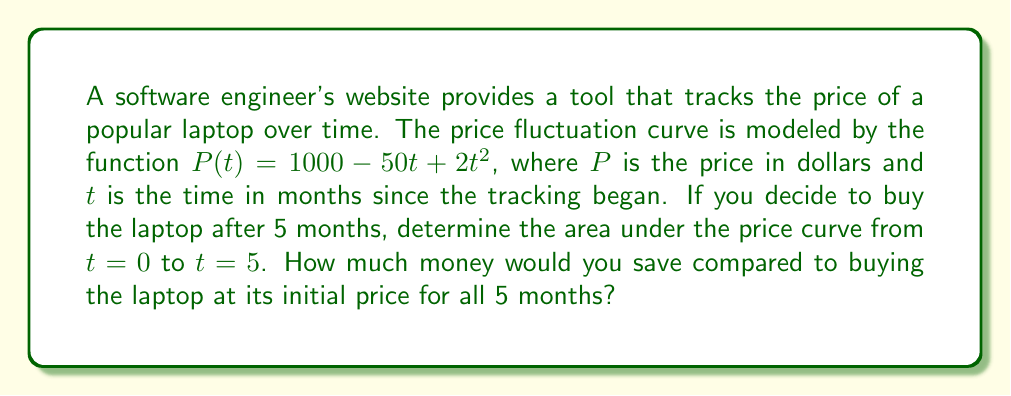Help me with this question. To solve this problem, we need to follow these steps:

1. Find the area under the price curve from $t=0$ to $t=5$.
2. Calculate the cost if the laptop was purchased at its initial price for all 5 months.
3. Determine the difference between the two values to find the savings.

Step 1: Area under the price curve

The area under the curve can be found using definite integration:

$$\int_0^5 (1000 - 50t + 2t^2) dt$$

Integrating each term:

$$\left[1000t - 25t^2 + \frac{2}{3}t^3\right]_0^5$$

Evaluating at the limits:

$$(5000 - 625 + \frac{250}{3}) - (0 - 0 + 0) = 5000 - 625 + 83.33 = 4458.33$$

The area under the curve is $4458.33$.

Step 2: Cost at initial price

The initial price is $P(0) = 1000$. For 5 months:

$$5 \times 1000 = 5000$$

Step 3: Savings

The savings is the difference between the cost at initial price and the area under the curve:

$$5000 - 4458.33 = 541.67$$

Therefore, you would save $541.67 by using the price tracking tool and buying after 5 months.
Answer: $541.67 